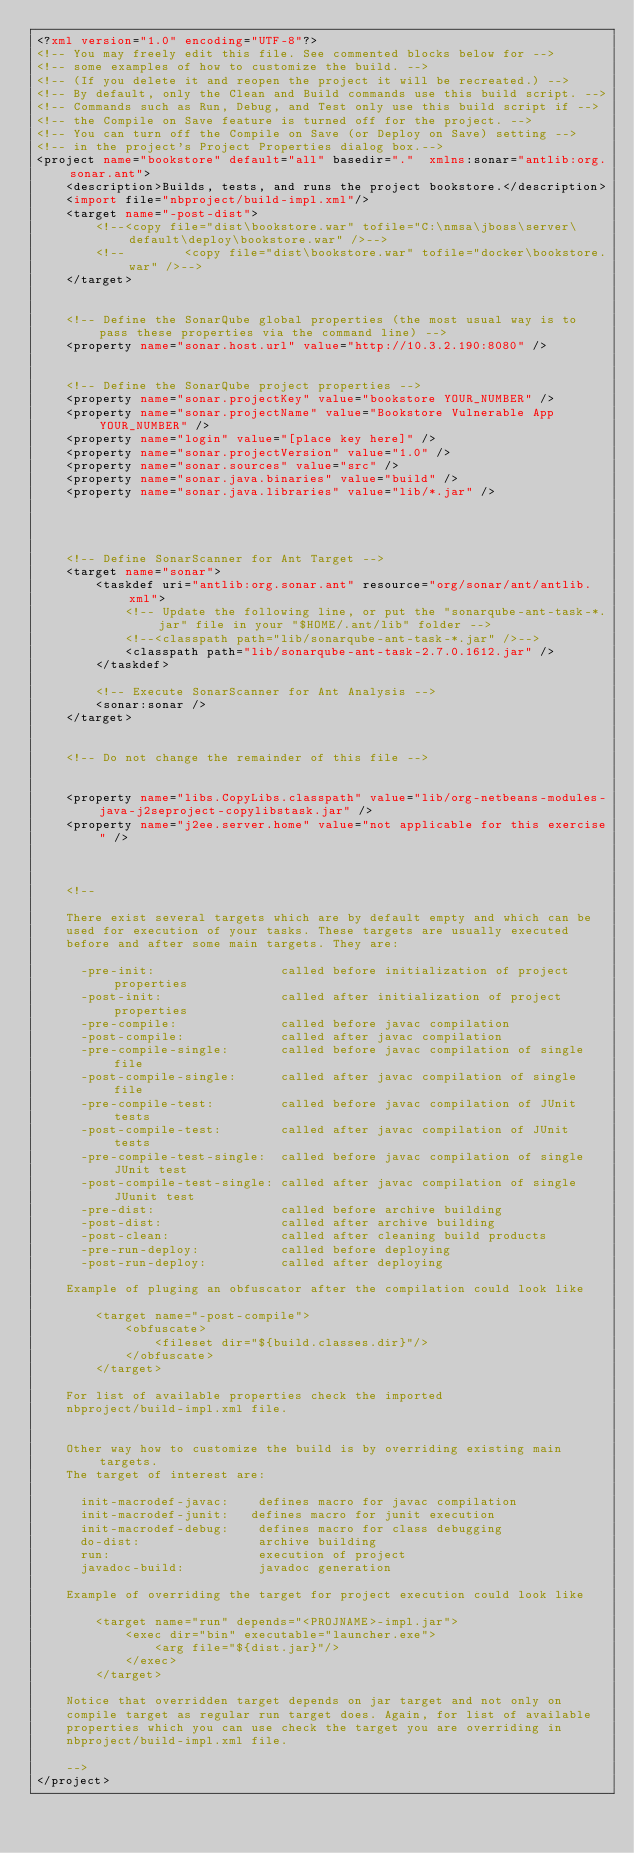<code> <loc_0><loc_0><loc_500><loc_500><_XML_><?xml version="1.0" encoding="UTF-8"?>
<!-- You may freely edit this file. See commented blocks below for -->
<!-- some examples of how to customize the build. -->
<!-- (If you delete it and reopen the project it will be recreated.) -->
<!-- By default, only the Clean and Build commands use this build script. -->
<!-- Commands such as Run, Debug, and Test only use this build script if -->
<!-- the Compile on Save feature is turned off for the project. -->
<!-- You can turn off the Compile on Save (or Deploy on Save) setting -->
<!-- in the project's Project Properties dialog box.-->
<project name="bookstore" default="all" basedir="."  xmlns:sonar="antlib:org.sonar.ant">
    <description>Builds, tests, and runs the project bookstore.</description>
    <import file="nbproject/build-impl.xml"/>
    <target name="-post-dist">
        <!--<copy file="dist\bookstore.war" tofile="C:\nmsa\jboss\server\default\deploy\bookstore.war" />-->
        <!--        <copy file="dist\bookstore.war" tofile="docker\bookstore.war" />-->
    </target>

    
    <!-- Define the SonarQube global properties (the most usual way is to pass these properties via the command line) -->
    <property name="sonar.host.url" value="http://10.3.2.190:8080" />
 
  
    <!-- Define the SonarQube project properties -->
    <property name="sonar.projectKey" value="bookstore YOUR_NUMBER" />
    <property name="sonar.projectName" value="Bookstore Vulnerable App YOUR_NUMBER" />
    <property name="login" value="[place key here]" />
    <property name="sonar.projectVersion" value="1.0" />
    <property name="sonar.sources" value="src" />
    <property name="sonar.java.binaries" value="build" />
    <property name="sonar.java.libraries" value="lib/*.jar" />

  


    <!-- Define SonarScanner for Ant Target -->
    <target name="sonar">
        <taskdef uri="antlib:org.sonar.ant" resource="org/sonar/ant/antlib.xml">
            <!-- Update the following line, or put the "sonarqube-ant-task-*.jar" file in your "$HOME/.ant/lib" folder -->
            <!--<classpath path="lib/sonarqube-ant-task-*.jar" />-->
            <classpath path="lib/sonarqube-ant-task-2.7.0.1612.jar" />
        </taskdef>
 
        <!-- Execute SonarScanner for Ant Analysis -->
        <sonar:sonar />
    </target>


    <!-- Do not change the remainder of this file -->


    <property name="libs.CopyLibs.classpath" value="lib/org-netbeans-modules-java-j2seproject-copylibstask.jar" />
    <property name="j2ee.server.home" value="not applicable for this exercise" />



    <!--

    There exist several targets which are by default empty and which can be
    used for execution of your tasks. These targets are usually executed
    before and after some main targets. They are:

      -pre-init:                 called before initialization of project properties
      -post-init:                called after initialization of project properties
      -pre-compile:              called before javac compilation
      -post-compile:             called after javac compilation
      -pre-compile-single:       called before javac compilation of single file
      -post-compile-single:      called after javac compilation of single file
      -pre-compile-test:         called before javac compilation of JUnit tests
      -post-compile-test:        called after javac compilation of JUnit tests
      -pre-compile-test-single:  called before javac compilation of single JUnit test
      -post-compile-test-single: called after javac compilation of single JUunit test
      -pre-dist:                 called before archive building
      -post-dist:                called after archive building
      -post-clean:               called after cleaning build products
      -pre-run-deploy:           called before deploying
      -post-run-deploy:          called after deploying

    Example of pluging an obfuscator after the compilation could look like

        <target name="-post-compile">
            <obfuscate>
                <fileset dir="${build.classes.dir}"/>
            </obfuscate>
        </target>

    For list of available properties check the imported
    nbproject/build-impl.xml file.


    Other way how to customize the build is by overriding existing main targets.
    The target of interest are:

      init-macrodef-javac:    defines macro for javac compilation
      init-macrodef-junit:   defines macro for junit execution
      init-macrodef-debug:    defines macro for class debugging
      do-dist:                archive building
      run:                    execution of project
      javadoc-build:          javadoc generation

    Example of overriding the target for project execution could look like

        <target name="run" depends="<PROJNAME>-impl.jar">
            <exec dir="bin" executable="launcher.exe">
                <arg file="${dist.jar}"/>
            </exec>
        </target>

    Notice that overridden target depends on jar target and not only on
    compile target as regular run target does. Again, for list of available
    properties which you can use check the target you are overriding in
    nbproject/build-impl.xml file.

    -->
</project>
</code> 